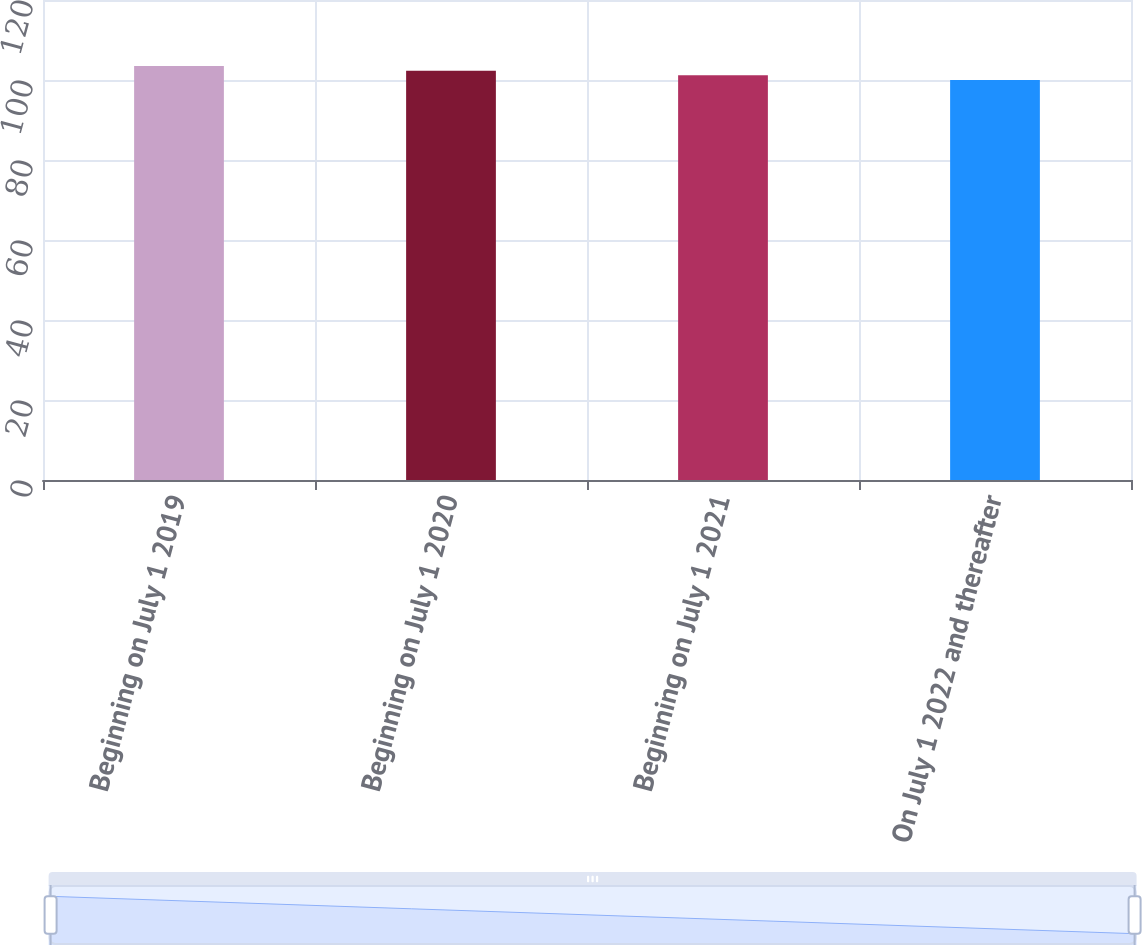Convert chart. <chart><loc_0><loc_0><loc_500><loc_500><bar_chart><fcel>Beginning on July 1 2019<fcel>Beginning on July 1 2020<fcel>Beginning on July 1 2021<fcel>On July 1 2022 and thereafter<nl><fcel>103.5<fcel>102.33<fcel>101.17<fcel>100<nl></chart> 